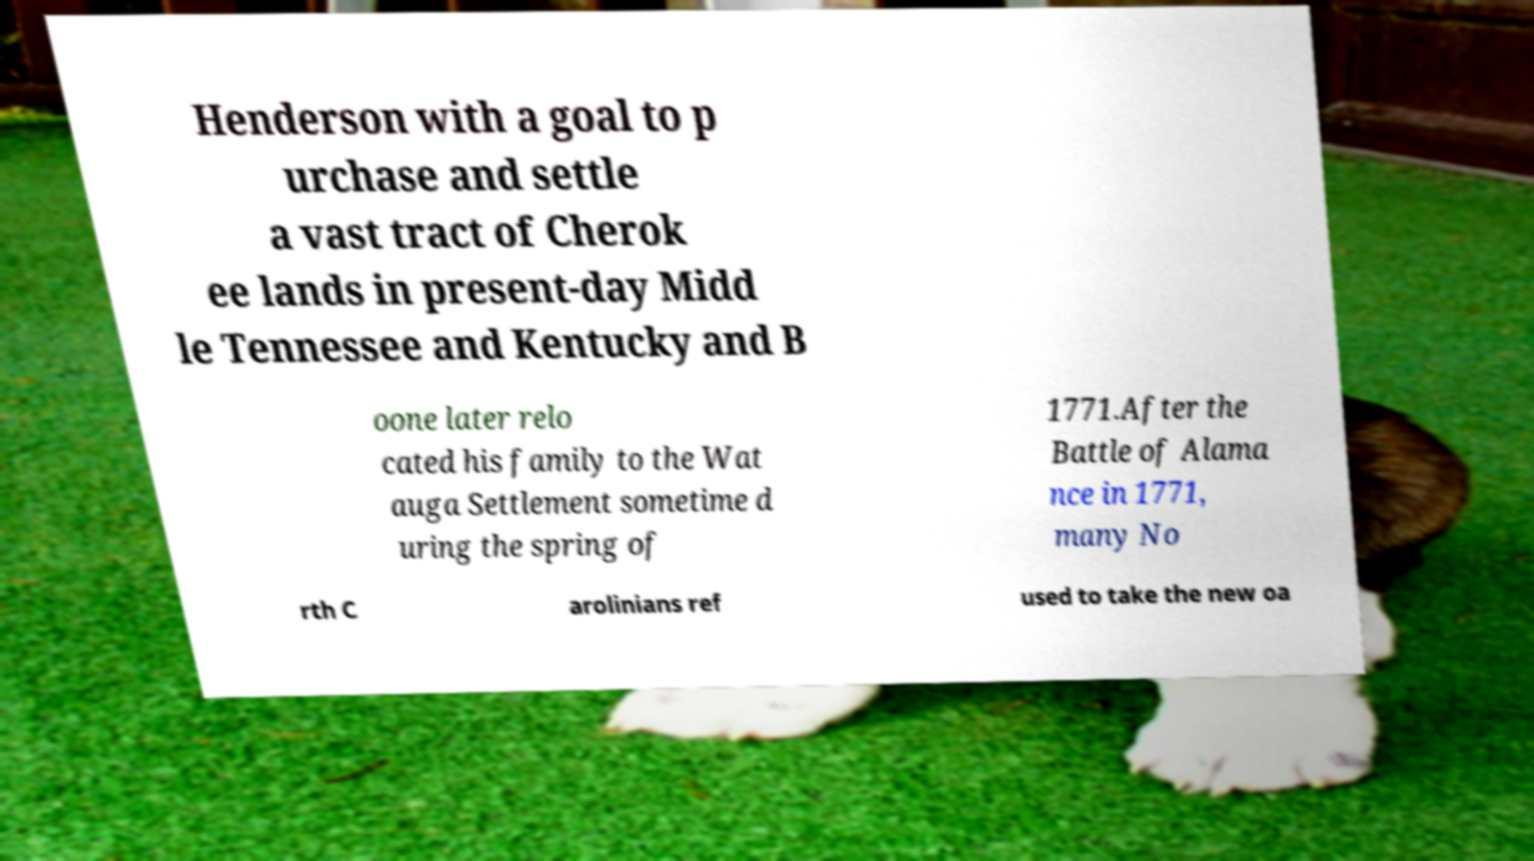Can you read and provide the text displayed in the image?This photo seems to have some interesting text. Can you extract and type it out for me? Henderson with a goal to p urchase and settle a vast tract of Cherok ee lands in present-day Midd le Tennessee and Kentucky and B oone later relo cated his family to the Wat auga Settlement sometime d uring the spring of 1771.After the Battle of Alama nce in 1771, many No rth C arolinians ref used to take the new oa 